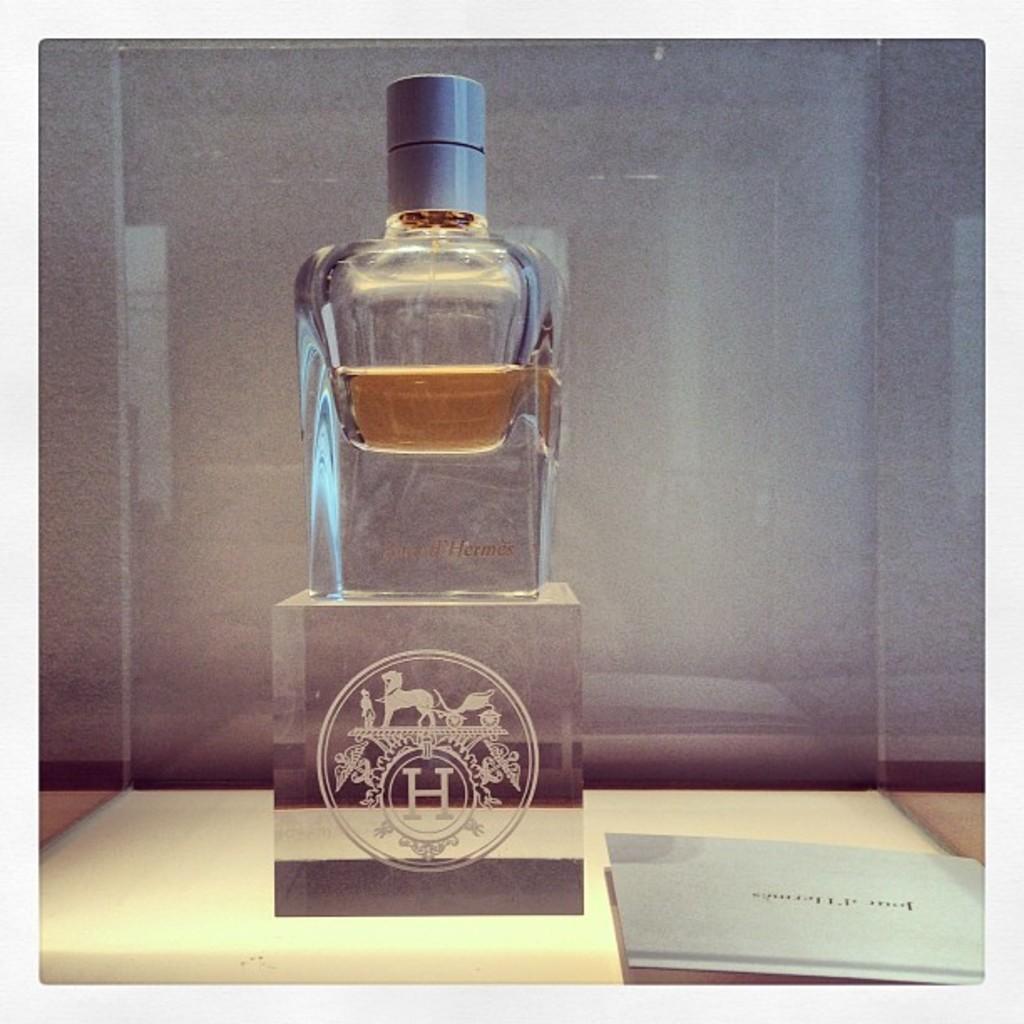Isthis a medal?
Your answer should be compact. No. 